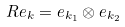<formula> <loc_0><loc_0><loc_500><loc_500>R { e } _ { k } = { e } _ { k _ { 1 } } \otimes { e } _ { k _ { 2 } }</formula> 